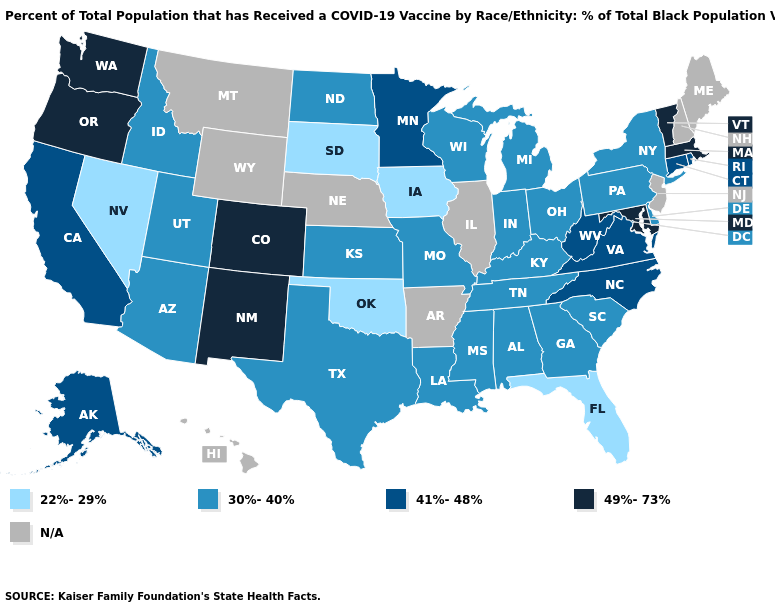What is the highest value in the USA?
Answer briefly. 49%-73%. What is the lowest value in states that border Michigan?
Be succinct. 30%-40%. What is the lowest value in states that border New Jersey?
Write a very short answer. 30%-40%. Does Massachusetts have the highest value in the Northeast?
Answer briefly. Yes. Which states have the lowest value in the USA?
Be succinct. Florida, Iowa, Nevada, Oklahoma, South Dakota. Does Rhode Island have the highest value in the USA?
Give a very brief answer. No. What is the value of Idaho?
Concise answer only. 30%-40%. Name the states that have a value in the range N/A?
Write a very short answer. Arkansas, Hawaii, Illinois, Maine, Montana, Nebraska, New Hampshire, New Jersey, Wyoming. What is the value of Idaho?
Answer briefly. 30%-40%. Among the states that border Oklahoma , which have the highest value?
Keep it brief. Colorado, New Mexico. Name the states that have a value in the range 22%-29%?
Write a very short answer. Florida, Iowa, Nevada, Oklahoma, South Dakota. Does the map have missing data?
Quick response, please. Yes. What is the value of Alabama?
Short answer required. 30%-40%. 